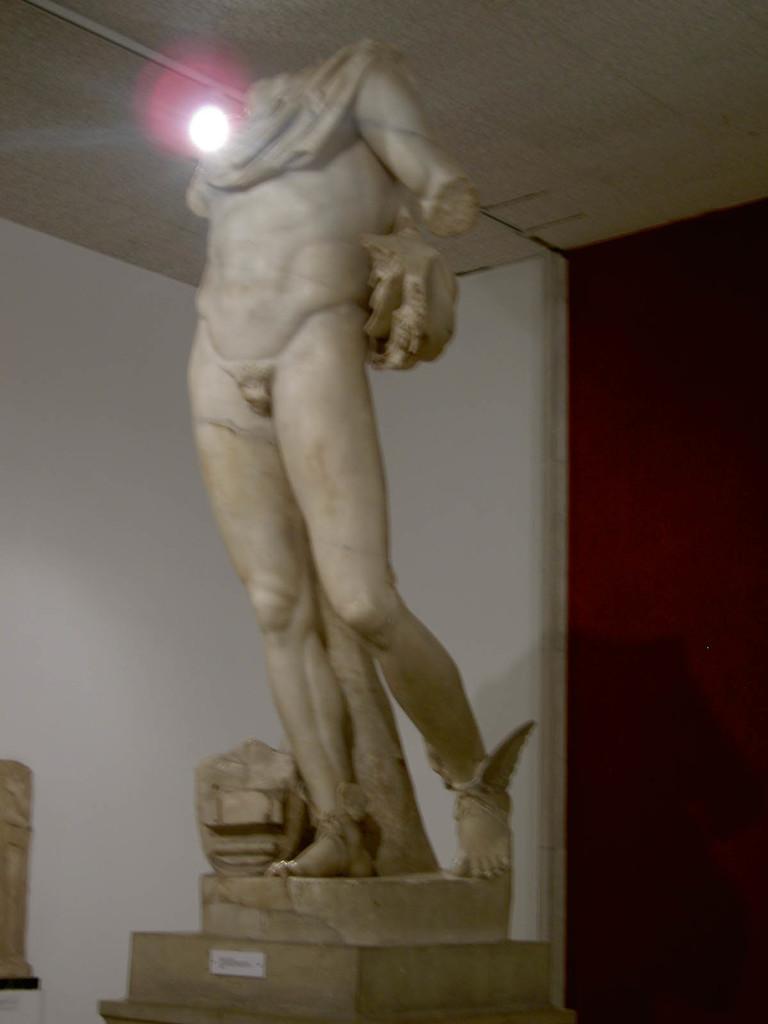How would you summarize this image in a sentence or two? In this image we can see there is a statue on the pillar. At the back there is a wall. And at the top there is a ceiling and light. 